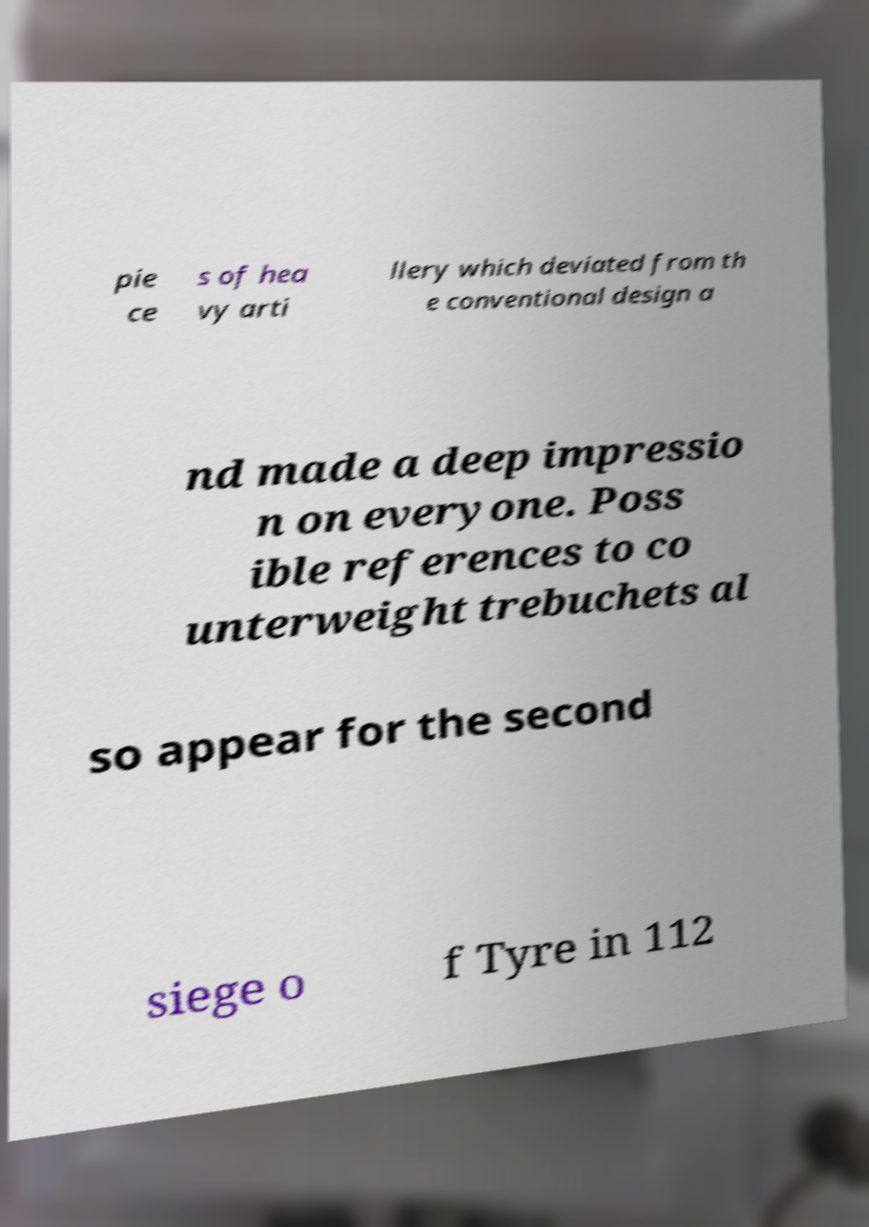Can you accurately transcribe the text from the provided image for me? pie ce s of hea vy arti llery which deviated from th e conventional design a nd made a deep impressio n on everyone. Poss ible references to co unterweight trebuchets al so appear for the second siege o f Tyre in 112 